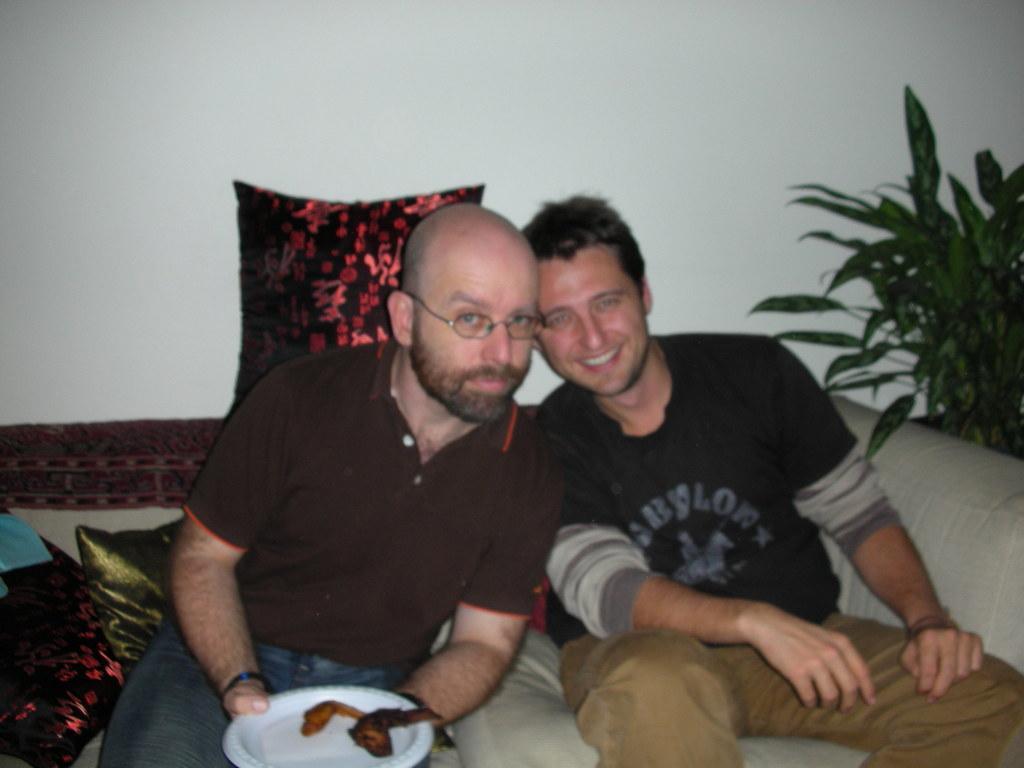In one or two sentences, can you explain what this image depicts? There are two men sitting on sofa and this man holding plate with food and we can see pillows. On the background we can see wall and plants. 